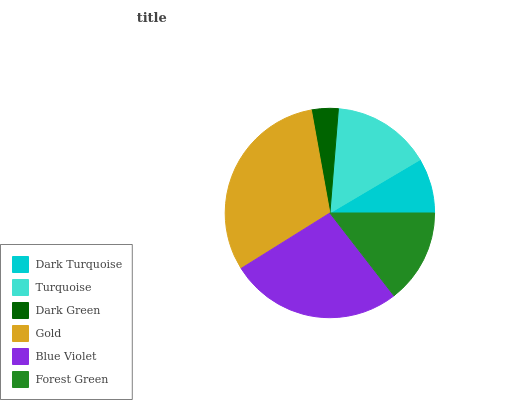Is Dark Green the minimum?
Answer yes or no. Yes. Is Gold the maximum?
Answer yes or no. Yes. Is Turquoise the minimum?
Answer yes or no. No. Is Turquoise the maximum?
Answer yes or no. No. Is Turquoise greater than Dark Turquoise?
Answer yes or no. Yes. Is Dark Turquoise less than Turquoise?
Answer yes or no. Yes. Is Dark Turquoise greater than Turquoise?
Answer yes or no. No. Is Turquoise less than Dark Turquoise?
Answer yes or no. No. Is Turquoise the high median?
Answer yes or no. Yes. Is Forest Green the low median?
Answer yes or no. Yes. Is Gold the high median?
Answer yes or no. No. Is Turquoise the low median?
Answer yes or no. No. 